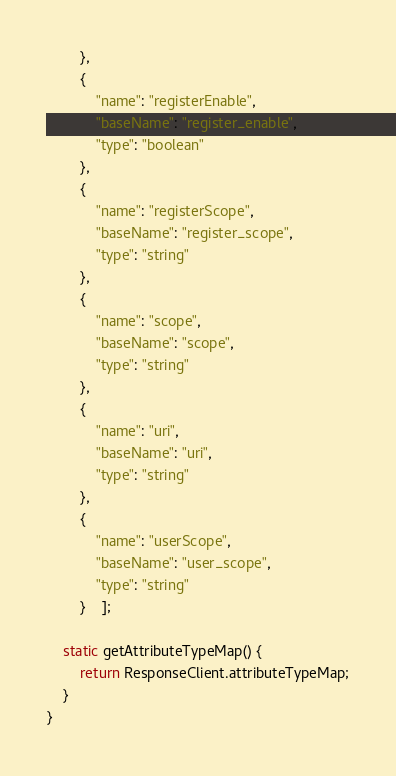<code> <loc_0><loc_0><loc_500><loc_500><_TypeScript_>        },
        {
            "name": "registerEnable",
            "baseName": "register_enable",
            "type": "boolean"
        },
        {
            "name": "registerScope",
            "baseName": "register_scope",
            "type": "string"
        },
        {
            "name": "scope",
            "baseName": "scope",
            "type": "string"
        },
        {
            "name": "uri",
            "baseName": "uri",
            "type": "string"
        },
        {
            "name": "userScope",
            "baseName": "user_scope",
            "type": "string"
        }    ];

    static getAttributeTypeMap() {
        return ResponseClient.attributeTypeMap;
    }
}

</code> 